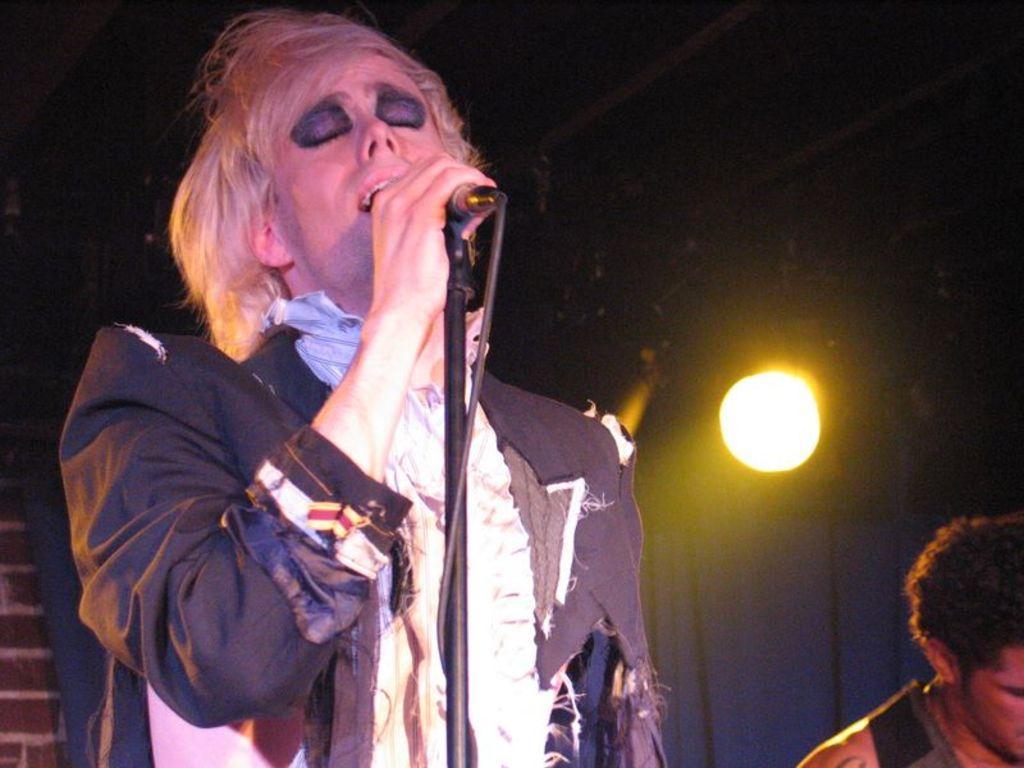Please provide a concise description of this image. In this picture we can see man singing on mic and beside to her other man and in background we can see light, curtain, wall and it is dark. 